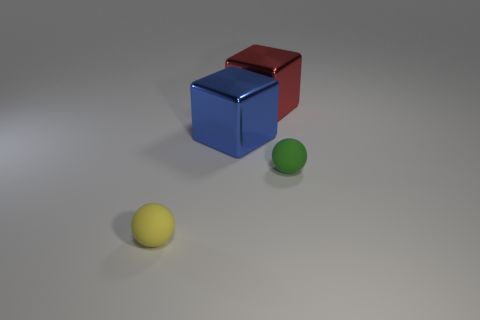The green rubber object that is the same size as the yellow matte thing is what shape?
Offer a very short reply. Sphere. What number of things are either rubber balls that are on the left side of the green matte ball or balls to the left of the large red block?
Your response must be concise. 1. What is the material of the object that is the same size as the green matte sphere?
Give a very brief answer. Rubber. How many other objects are there of the same material as the green sphere?
Offer a terse response. 1. Are there an equal number of blue shiny cubes in front of the large blue metallic thing and tiny green balls that are left of the small yellow object?
Your answer should be compact. Yes. What number of gray things are things or big metallic objects?
Give a very brief answer. 0. Are there fewer red shiny objects than metallic cubes?
Your answer should be very brief. Yes. There is a rubber ball that is to the left of the big block behind the blue thing; how many small objects are behind it?
Offer a terse response. 1. What is the size of the rubber sphere in front of the tiny green object?
Your answer should be very brief. Small. There is a tiny matte object right of the yellow sphere; is its shape the same as the red thing?
Offer a terse response. No. 